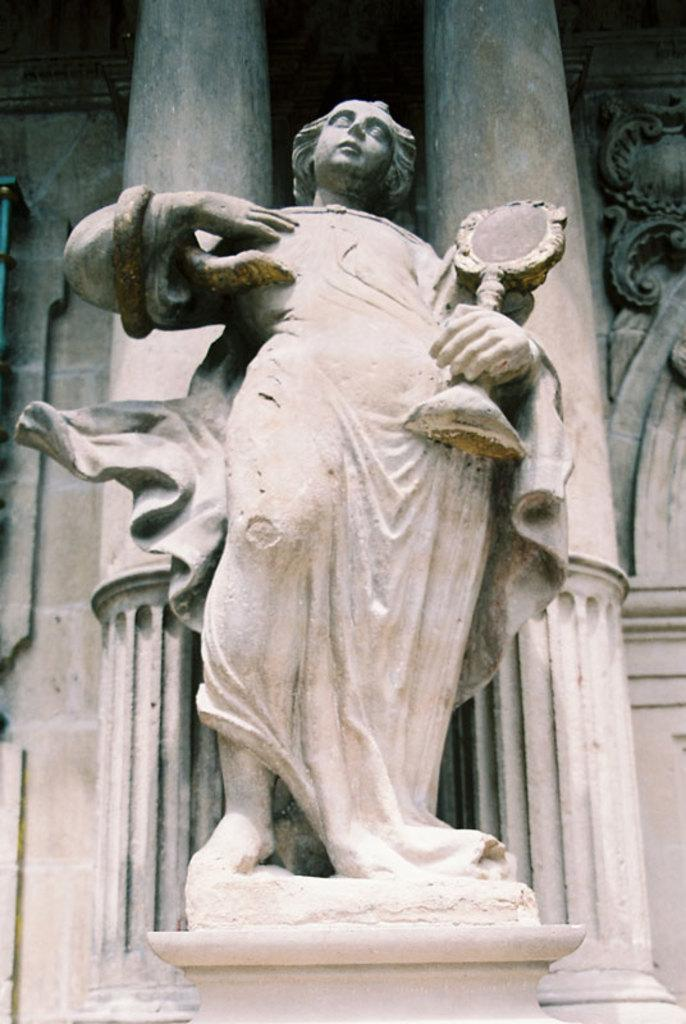What is the main subject in the image? There is a statue in the image. How is the statue positioned in the image? The statue is on a stand. What can be seen in the background of the image? There are pillars and a wall in the background of the image. What type of board is the statue performing on in the image? There is no board present in the image, and the statue is not performing on anything. 